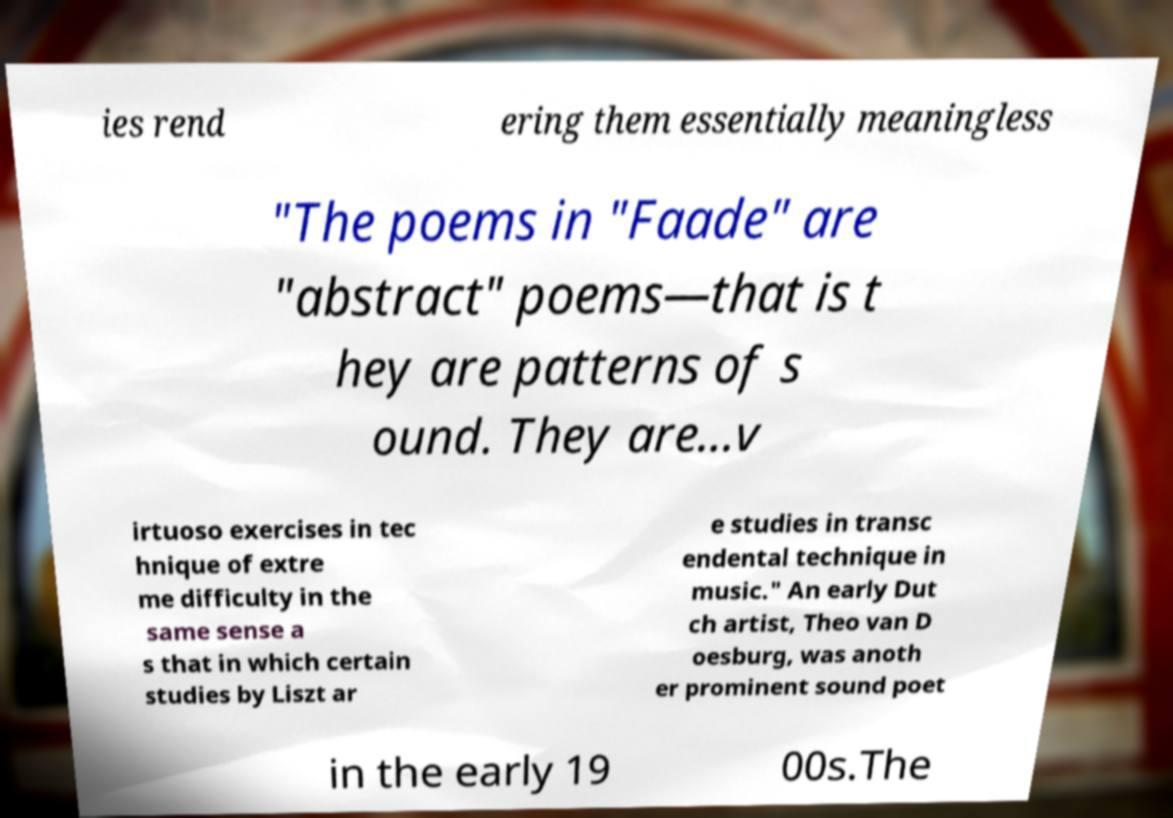For documentation purposes, I need the text within this image transcribed. Could you provide that? ies rend ering them essentially meaningless "The poems in "Faade" are "abstract" poems—that is t hey are patterns of s ound. They are...v irtuoso exercises in tec hnique of extre me difficulty in the same sense a s that in which certain studies by Liszt ar e studies in transc endental technique in music." An early Dut ch artist, Theo van D oesburg, was anoth er prominent sound poet in the early 19 00s.The 